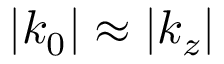Convert formula to latex. <formula><loc_0><loc_0><loc_500><loc_500>| k _ { 0 } | \approx | k _ { z } |</formula> 